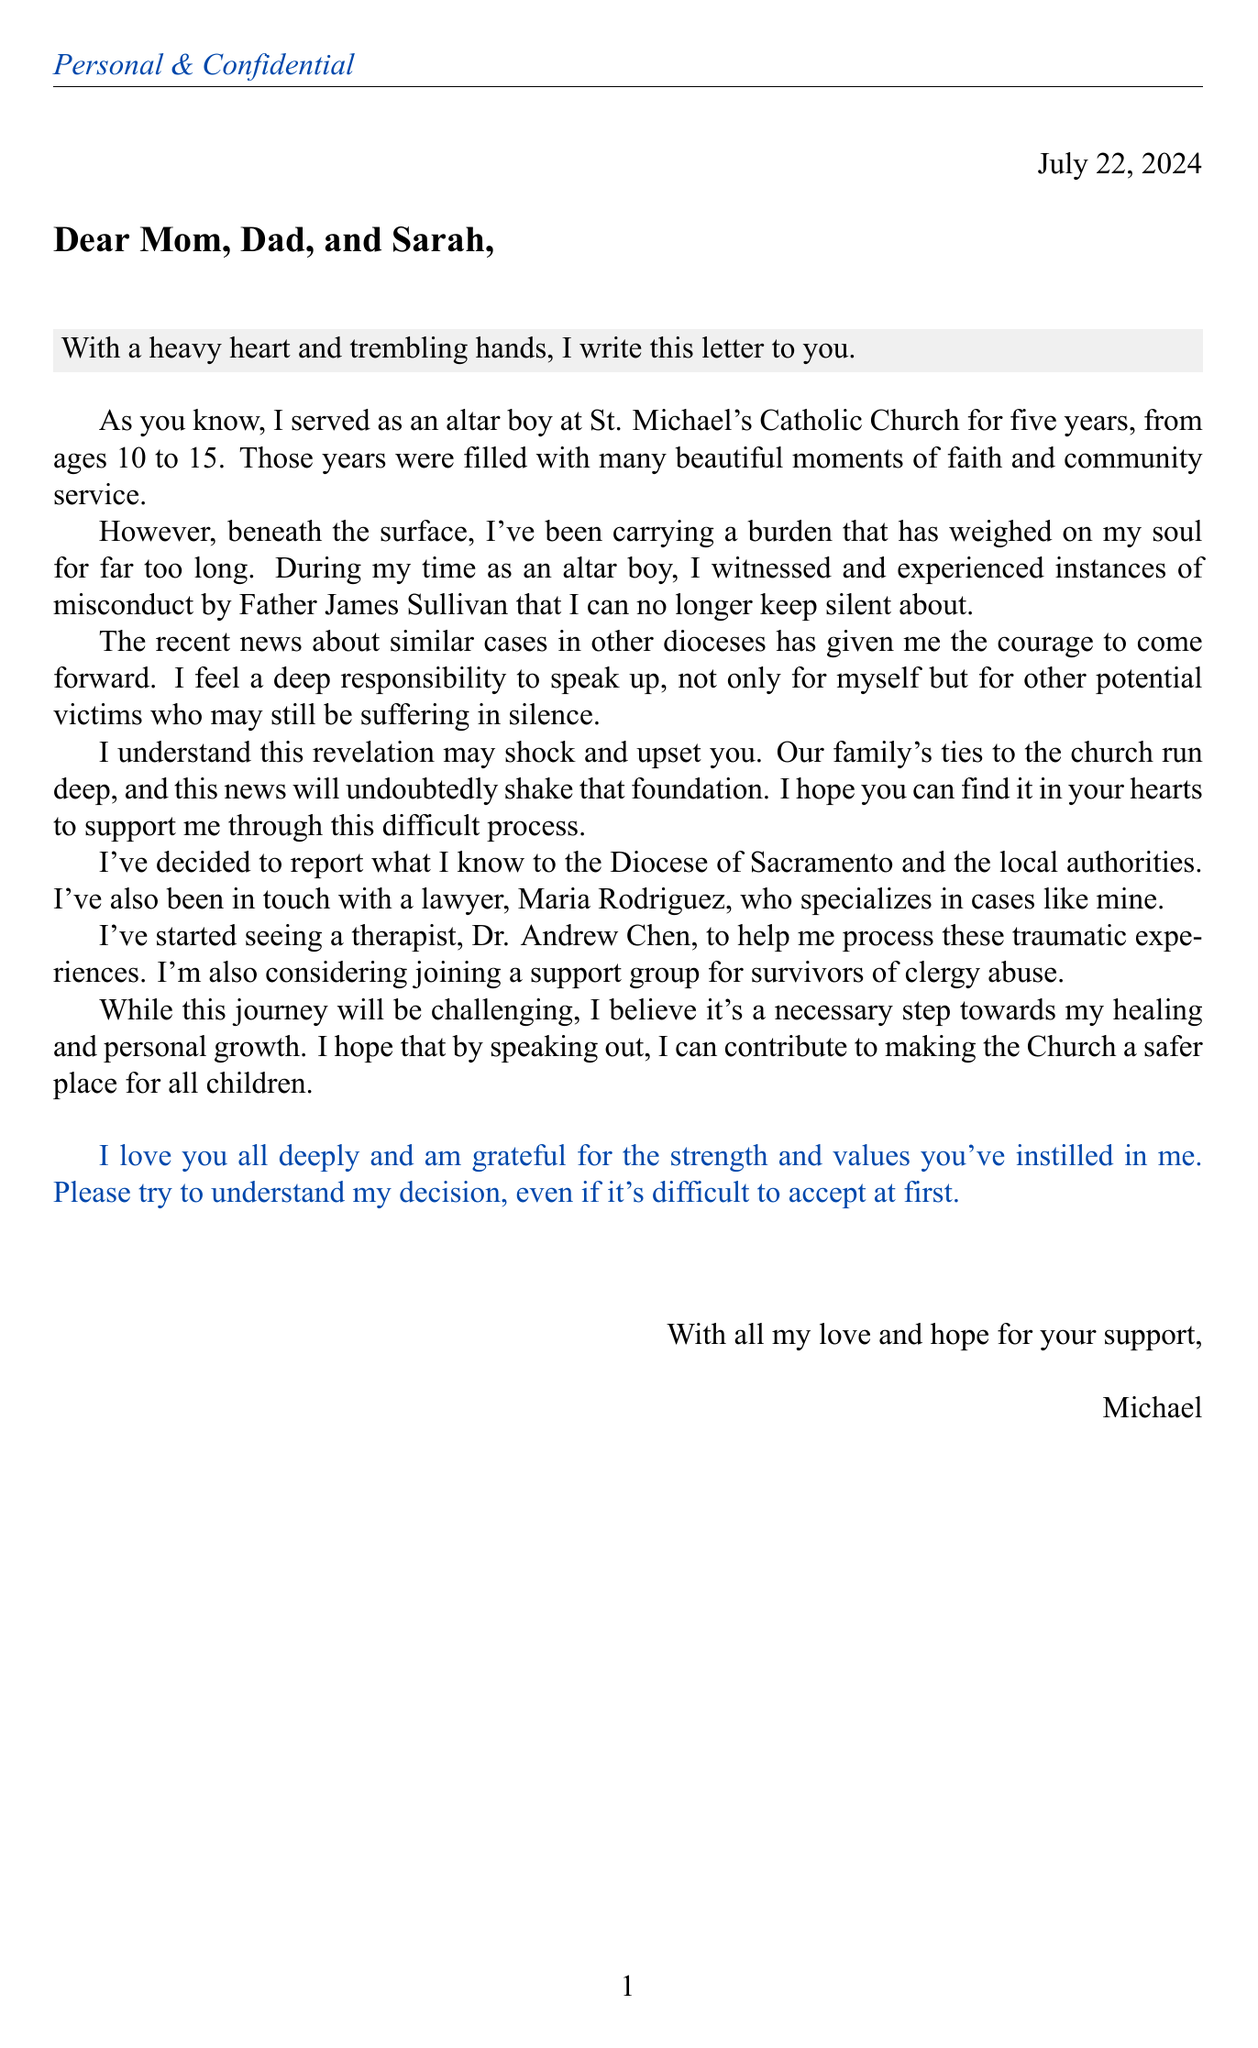What is the name of the church mentioned? The letter mentions St. Michael's Catholic Church where the author served as an altar boy.
Answer: St. Michael's Catholic Church Who did the author witness misconduct from? The document states that the misconduct was by Father James Sullivan.
Answer: Father James Sullivan How many years did the author serve as an altar boy? The letter indicates that the author served for five years, from ages 10 to 15.
Answer: five years What is the name of the author's therapist? The author mentions that their therapist's name is Dr. Andrew Chen.
Answer: Dr. Andrew Chen What legal action has the author taken? The letter specifies that the author has decided to report to the Diocese of Sacramento and local authorities.
Answer: report to the Diocese of Sacramento and local authorities What is the author's relationship with Maria Rodriguez? The author mentions that they have been in touch with a lawyer named Maria Rodriguez.
Answer: lawyer What emotions does the author express in the opening of the letter? The author describes their emotional state as having a "heavy heart and trembling hands."
Answer: heavy heart and trembling hands What does the author hope to achieve by coming forward? The author aims to contribute to making the Church a safer place for all children.
Answer: making the Church a safer place for all children What request does the author make to their family? The author requests for their family to support them through this difficult process.
Answer: support me through this difficult process 